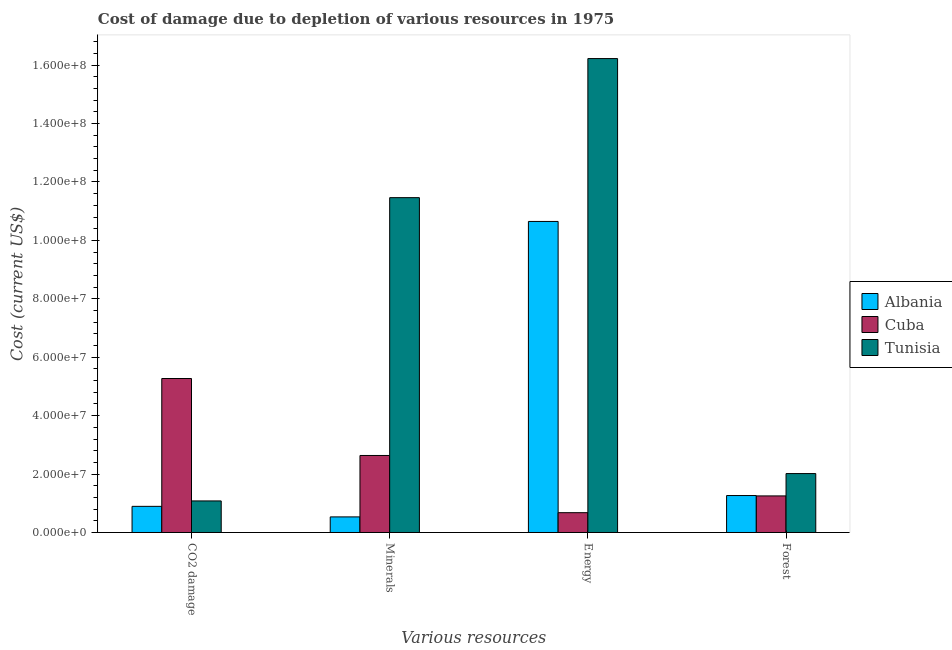How many different coloured bars are there?
Your response must be concise. 3. Are the number of bars per tick equal to the number of legend labels?
Ensure brevity in your answer.  Yes. Are the number of bars on each tick of the X-axis equal?
Make the answer very short. Yes. What is the label of the 4th group of bars from the left?
Provide a succinct answer. Forest. What is the cost of damage due to depletion of coal in Tunisia?
Give a very brief answer. 1.08e+07. Across all countries, what is the maximum cost of damage due to depletion of coal?
Your answer should be very brief. 5.27e+07. Across all countries, what is the minimum cost of damage due to depletion of energy?
Your response must be concise. 6.78e+06. In which country was the cost of damage due to depletion of energy maximum?
Keep it short and to the point. Tunisia. In which country was the cost of damage due to depletion of coal minimum?
Your response must be concise. Albania. What is the total cost of damage due to depletion of coal in the graph?
Ensure brevity in your answer.  7.25e+07. What is the difference between the cost of damage due to depletion of forests in Albania and that in Tunisia?
Provide a succinct answer. -7.52e+06. What is the difference between the cost of damage due to depletion of energy in Cuba and the cost of damage due to depletion of minerals in Albania?
Give a very brief answer. 1.44e+06. What is the average cost of damage due to depletion of coal per country?
Offer a very short reply. 2.42e+07. What is the difference between the cost of damage due to depletion of minerals and cost of damage due to depletion of forests in Tunisia?
Your answer should be compact. 9.45e+07. What is the ratio of the cost of damage due to depletion of coal in Cuba to that in Albania?
Your answer should be very brief. 5.89. Is the cost of damage due to depletion of minerals in Cuba less than that in Tunisia?
Provide a succinct answer. Yes. What is the difference between the highest and the second highest cost of damage due to depletion of coal?
Offer a terse response. 4.19e+07. What is the difference between the highest and the lowest cost of damage due to depletion of coal?
Offer a terse response. 4.38e+07. What does the 2nd bar from the left in Minerals represents?
Keep it short and to the point. Cuba. What does the 3rd bar from the right in Forest represents?
Make the answer very short. Albania. What is the difference between two consecutive major ticks on the Y-axis?
Provide a succinct answer. 2.00e+07. Does the graph contain any zero values?
Your answer should be compact. No. How many legend labels are there?
Offer a terse response. 3. What is the title of the graph?
Your answer should be compact. Cost of damage due to depletion of various resources in 1975 . Does "Guinea" appear as one of the legend labels in the graph?
Make the answer very short. No. What is the label or title of the X-axis?
Ensure brevity in your answer.  Various resources. What is the label or title of the Y-axis?
Offer a very short reply. Cost (current US$). What is the Cost (current US$) in Albania in CO2 damage?
Your answer should be very brief. 8.95e+06. What is the Cost (current US$) in Cuba in CO2 damage?
Offer a very short reply. 5.27e+07. What is the Cost (current US$) of Tunisia in CO2 damage?
Your answer should be compact. 1.08e+07. What is the Cost (current US$) in Albania in Minerals?
Give a very brief answer. 5.34e+06. What is the Cost (current US$) in Cuba in Minerals?
Offer a very short reply. 2.64e+07. What is the Cost (current US$) of Tunisia in Minerals?
Provide a short and direct response. 1.15e+08. What is the Cost (current US$) in Albania in Energy?
Keep it short and to the point. 1.06e+08. What is the Cost (current US$) in Cuba in Energy?
Give a very brief answer. 6.78e+06. What is the Cost (current US$) of Tunisia in Energy?
Offer a terse response. 1.62e+08. What is the Cost (current US$) in Albania in Forest?
Your answer should be very brief. 1.26e+07. What is the Cost (current US$) in Cuba in Forest?
Provide a succinct answer. 1.25e+07. What is the Cost (current US$) of Tunisia in Forest?
Give a very brief answer. 2.02e+07. Across all Various resources, what is the maximum Cost (current US$) in Albania?
Offer a very short reply. 1.06e+08. Across all Various resources, what is the maximum Cost (current US$) of Cuba?
Offer a terse response. 5.27e+07. Across all Various resources, what is the maximum Cost (current US$) of Tunisia?
Offer a very short reply. 1.62e+08. Across all Various resources, what is the minimum Cost (current US$) of Albania?
Offer a very short reply. 5.34e+06. Across all Various resources, what is the minimum Cost (current US$) of Cuba?
Give a very brief answer. 6.78e+06. Across all Various resources, what is the minimum Cost (current US$) of Tunisia?
Keep it short and to the point. 1.08e+07. What is the total Cost (current US$) in Albania in the graph?
Your response must be concise. 1.33e+08. What is the total Cost (current US$) in Cuba in the graph?
Provide a succinct answer. 9.84e+07. What is the total Cost (current US$) in Tunisia in the graph?
Keep it short and to the point. 3.08e+08. What is the difference between the Cost (current US$) in Albania in CO2 damage and that in Minerals?
Your answer should be compact. 3.61e+06. What is the difference between the Cost (current US$) in Cuba in CO2 damage and that in Minerals?
Keep it short and to the point. 2.64e+07. What is the difference between the Cost (current US$) of Tunisia in CO2 damage and that in Minerals?
Make the answer very short. -1.04e+08. What is the difference between the Cost (current US$) in Albania in CO2 damage and that in Energy?
Provide a short and direct response. -9.75e+07. What is the difference between the Cost (current US$) in Cuba in CO2 damage and that in Energy?
Provide a succinct answer. 4.59e+07. What is the difference between the Cost (current US$) in Tunisia in CO2 damage and that in Energy?
Ensure brevity in your answer.  -1.51e+08. What is the difference between the Cost (current US$) in Albania in CO2 damage and that in Forest?
Provide a succinct answer. -3.70e+06. What is the difference between the Cost (current US$) of Cuba in CO2 damage and that in Forest?
Make the answer very short. 4.02e+07. What is the difference between the Cost (current US$) in Tunisia in CO2 damage and that in Forest?
Ensure brevity in your answer.  -9.36e+06. What is the difference between the Cost (current US$) in Albania in Minerals and that in Energy?
Offer a terse response. -1.01e+08. What is the difference between the Cost (current US$) of Cuba in Minerals and that in Energy?
Offer a very short reply. 1.96e+07. What is the difference between the Cost (current US$) in Tunisia in Minerals and that in Energy?
Provide a succinct answer. -4.76e+07. What is the difference between the Cost (current US$) in Albania in Minerals and that in Forest?
Keep it short and to the point. -7.31e+06. What is the difference between the Cost (current US$) of Cuba in Minerals and that in Forest?
Provide a short and direct response. 1.38e+07. What is the difference between the Cost (current US$) in Tunisia in Minerals and that in Forest?
Provide a short and direct response. 9.45e+07. What is the difference between the Cost (current US$) of Albania in Energy and that in Forest?
Give a very brief answer. 9.38e+07. What is the difference between the Cost (current US$) in Cuba in Energy and that in Forest?
Make the answer very short. -5.74e+06. What is the difference between the Cost (current US$) of Tunisia in Energy and that in Forest?
Offer a terse response. 1.42e+08. What is the difference between the Cost (current US$) in Albania in CO2 damage and the Cost (current US$) in Cuba in Minerals?
Make the answer very short. -1.74e+07. What is the difference between the Cost (current US$) in Albania in CO2 damage and the Cost (current US$) in Tunisia in Minerals?
Offer a very short reply. -1.06e+08. What is the difference between the Cost (current US$) in Cuba in CO2 damage and the Cost (current US$) in Tunisia in Minerals?
Give a very brief answer. -6.19e+07. What is the difference between the Cost (current US$) in Albania in CO2 damage and the Cost (current US$) in Cuba in Energy?
Provide a succinct answer. 2.17e+06. What is the difference between the Cost (current US$) in Albania in CO2 damage and the Cost (current US$) in Tunisia in Energy?
Make the answer very short. -1.53e+08. What is the difference between the Cost (current US$) in Cuba in CO2 damage and the Cost (current US$) in Tunisia in Energy?
Ensure brevity in your answer.  -1.10e+08. What is the difference between the Cost (current US$) in Albania in CO2 damage and the Cost (current US$) in Cuba in Forest?
Your answer should be very brief. -3.57e+06. What is the difference between the Cost (current US$) in Albania in CO2 damage and the Cost (current US$) in Tunisia in Forest?
Give a very brief answer. -1.12e+07. What is the difference between the Cost (current US$) of Cuba in CO2 damage and the Cost (current US$) of Tunisia in Forest?
Your response must be concise. 3.25e+07. What is the difference between the Cost (current US$) in Albania in Minerals and the Cost (current US$) in Cuba in Energy?
Offer a terse response. -1.44e+06. What is the difference between the Cost (current US$) in Albania in Minerals and the Cost (current US$) in Tunisia in Energy?
Offer a very short reply. -1.57e+08. What is the difference between the Cost (current US$) of Cuba in Minerals and the Cost (current US$) of Tunisia in Energy?
Your response must be concise. -1.36e+08. What is the difference between the Cost (current US$) in Albania in Minerals and the Cost (current US$) in Cuba in Forest?
Your answer should be very brief. -7.18e+06. What is the difference between the Cost (current US$) of Albania in Minerals and the Cost (current US$) of Tunisia in Forest?
Provide a succinct answer. -1.48e+07. What is the difference between the Cost (current US$) of Cuba in Minerals and the Cost (current US$) of Tunisia in Forest?
Ensure brevity in your answer.  6.19e+06. What is the difference between the Cost (current US$) of Albania in Energy and the Cost (current US$) of Cuba in Forest?
Make the answer very short. 9.40e+07. What is the difference between the Cost (current US$) of Albania in Energy and the Cost (current US$) of Tunisia in Forest?
Provide a succinct answer. 8.63e+07. What is the difference between the Cost (current US$) of Cuba in Energy and the Cost (current US$) of Tunisia in Forest?
Ensure brevity in your answer.  -1.34e+07. What is the average Cost (current US$) in Albania per Various resources?
Offer a very short reply. 3.34e+07. What is the average Cost (current US$) in Cuba per Various resources?
Offer a very short reply. 2.46e+07. What is the average Cost (current US$) in Tunisia per Various resources?
Offer a very short reply. 7.70e+07. What is the difference between the Cost (current US$) of Albania and Cost (current US$) of Cuba in CO2 damage?
Your response must be concise. -4.38e+07. What is the difference between the Cost (current US$) of Albania and Cost (current US$) of Tunisia in CO2 damage?
Give a very brief answer. -1.86e+06. What is the difference between the Cost (current US$) of Cuba and Cost (current US$) of Tunisia in CO2 damage?
Your answer should be compact. 4.19e+07. What is the difference between the Cost (current US$) of Albania and Cost (current US$) of Cuba in Minerals?
Provide a short and direct response. -2.10e+07. What is the difference between the Cost (current US$) of Albania and Cost (current US$) of Tunisia in Minerals?
Provide a succinct answer. -1.09e+08. What is the difference between the Cost (current US$) of Cuba and Cost (current US$) of Tunisia in Minerals?
Ensure brevity in your answer.  -8.83e+07. What is the difference between the Cost (current US$) in Albania and Cost (current US$) in Cuba in Energy?
Give a very brief answer. 9.97e+07. What is the difference between the Cost (current US$) in Albania and Cost (current US$) in Tunisia in Energy?
Make the answer very short. -5.58e+07. What is the difference between the Cost (current US$) of Cuba and Cost (current US$) of Tunisia in Energy?
Make the answer very short. -1.55e+08. What is the difference between the Cost (current US$) of Albania and Cost (current US$) of Cuba in Forest?
Offer a very short reply. 1.28e+05. What is the difference between the Cost (current US$) of Albania and Cost (current US$) of Tunisia in Forest?
Your response must be concise. -7.52e+06. What is the difference between the Cost (current US$) in Cuba and Cost (current US$) in Tunisia in Forest?
Provide a short and direct response. -7.65e+06. What is the ratio of the Cost (current US$) of Albania in CO2 damage to that in Minerals?
Your answer should be very brief. 1.68. What is the ratio of the Cost (current US$) of Cuba in CO2 damage to that in Minerals?
Keep it short and to the point. 2. What is the ratio of the Cost (current US$) of Tunisia in CO2 damage to that in Minerals?
Offer a terse response. 0.09. What is the ratio of the Cost (current US$) of Albania in CO2 damage to that in Energy?
Make the answer very short. 0.08. What is the ratio of the Cost (current US$) in Cuba in CO2 damage to that in Energy?
Offer a very short reply. 7.77. What is the ratio of the Cost (current US$) in Tunisia in CO2 damage to that in Energy?
Give a very brief answer. 0.07. What is the ratio of the Cost (current US$) in Albania in CO2 damage to that in Forest?
Your response must be concise. 0.71. What is the ratio of the Cost (current US$) in Cuba in CO2 damage to that in Forest?
Your answer should be very brief. 4.21. What is the ratio of the Cost (current US$) of Tunisia in CO2 damage to that in Forest?
Offer a terse response. 0.54. What is the ratio of the Cost (current US$) in Albania in Minerals to that in Energy?
Keep it short and to the point. 0.05. What is the ratio of the Cost (current US$) in Cuba in Minerals to that in Energy?
Your answer should be very brief. 3.89. What is the ratio of the Cost (current US$) in Tunisia in Minerals to that in Energy?
Offer a terse response. 0.71. What is the ratio of the Cost (current US$) in Albania in Minerals to that in Forest?
Provide a succinct answer. 0.42. What is the ratio of the Cost (current US$) in Cuba in Minerals to that in Forest?
Make the answer very short. 2.11. What is the ratio of the Cost (current US$) in Tunisia in Minerals to that in Forest?
Your response must be concise. 5.68. What is the ratio of the Cost (current US$) in Albania in Energy to that in Forest?
Offer a terse response. 8.42. What is the ratio of the Cost (current US$) of Cuba in Energy to that in Forest?
Keep it short and to the point. 0.54. What is the ratio of the Cost (current US$) in Tunisia in Energy to that in Forest?
Offer a very short reply. 8.04. What is the difference between the highest and the second highest Cost (current US$) of Albania?
Offer a terse response. 9.38e+07. What is the difference between the highest and the second highest Cost (current US$) of Cuba?
Ensure brevity in your answer.  2.64e+07. What is the difference between the highest and the second highest Cost (current US$) of Tunisia?
Keep it short and to the point. 4.76e+07. What is the difference between the highest and the lowest Cost (current US$) of Albania?
Provide a succinct answer. 1.01e+08. What is the difference between the highest and the lowest Cost (current US$) in Cuba?
Keep it short and to the point. 4.59e+07. What is the difference between the highest and the lowest Cost (current US$) of Tunisia?
Provide a succinct answer. 1.51e+08. 